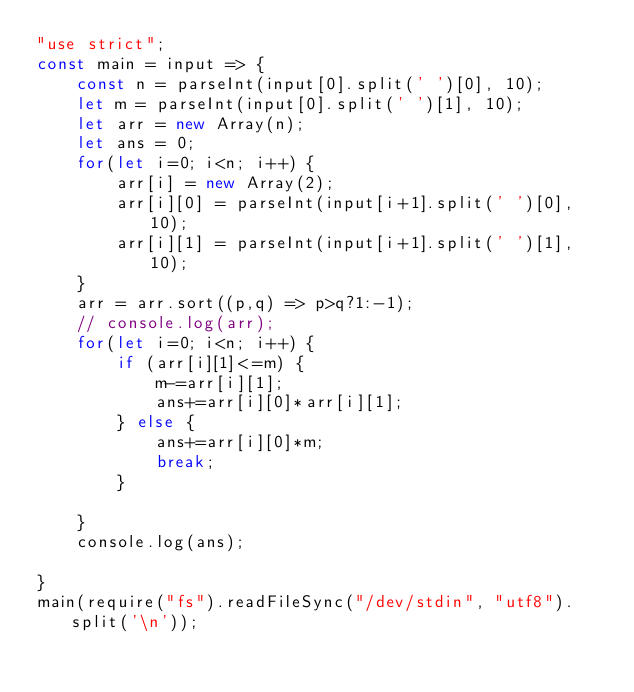<code> <loc_0><loc_0><loc_500><loc_500><_JavaScript_>"use strict";
const main = input => {
    const n = parseInt(input[0].split(' ')[0], 10);
    let m = parseInt(input[0].split(' ')[1], 10);
    let arr = new Array(n);
    let ans = 0;
    for(let i=0; i<n; i++) {
        arr[i] = new Array(2);
        arr[i][0] = parseInt(input[i+1].split(' ')[0], 10);
        arr[i][1] = parseInt(input[i+1].split(' ')[1], 10);
    }
    arr = arr.sort((p,q) => p>q?1:-1);
    // console.log(arr);
    for(let i=0; i<n; i++) {
        if (arr[i][1]<=m) {
            m-=arr[i][1];
            ans+=arr[i][0]*arr[i][1];
        } else {
            ans+=arr[i][0]*m;
            break;
        }
        
    }
    console.log(ans);
    
}
main(require("fs").readFileSync("/dev/stdin", "utf8").split('\n'));</code> 